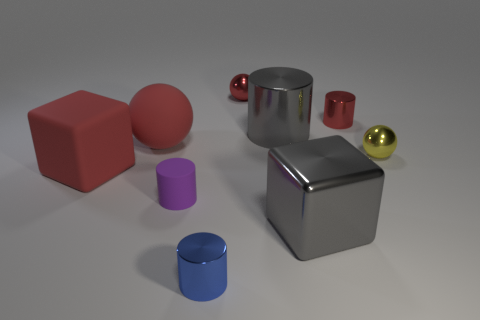Subtract all cylinders. How many objects are left? 5 Add 1 large red rubber things. How many large red rubber things exist? 3 Subtract all yellow spheres. How many spheres are left? 2 Subtract all red spheres. How many spheres are left? 1 Subtract 0 cyan cylinders. How many objects are left? 9 Subtract 1 cylinders. How many cylinders are left? 3 Subtract all purple cubes. Subtract all purple balls. How many cubes are left? 2 Subtract all blue cylinders. How many gray cubes are left? 1 Subtract all large metal cubes. Subtract all large rubber spheres. How many objects are left? 7 Add 1 large red matte balls. How many large red matte balls are left? 2 